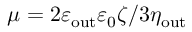Convert formula to latex. <formula><loc_0><loc_0><loc_500><loc_500>\mu = 2 \varepsilon _ { o u t } \varepsilon _ { 0 } \zeta / 3 \eta _ { o u t }</formula> 